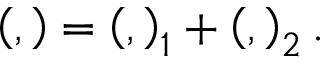Convert formula to latex. <formula><loc_0><loc_0><loc_500><loc_500>\left ( , \right ) = \left ( , \right ) _ { 1 } + \left ( , \right ) _ { 2 } .</formula> 